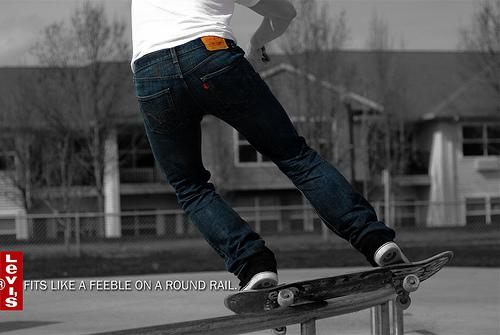Question: what is the man doing?
Choices:
A. Bicycling.
B. Skiing.
C. Skateboarding.
D. Surfing.
Answer with the letter. Answer: C Question: who is on the skateboard?
Choices:
A. A man.
B. A boy.
C. A girl.
D. A dog.
Answer with the letter. Answer: A 